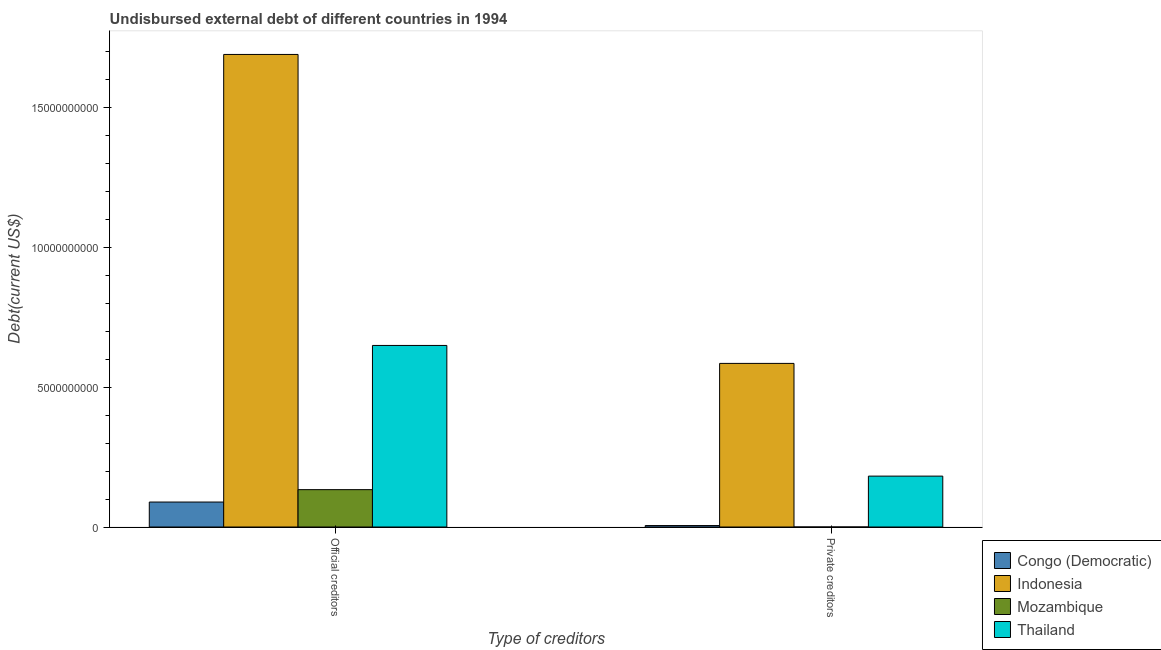How many groups of bars are there?
Keep it short and to the point. 2. Are the number of bars per tick equal to the number of legend labels?
Your response must be concise. Yes. What is the label of the 1st group of bars from the left?
Make the answer very short. Official creditors. What is the undisbursed external debt of official creditors in Mozambique?
Provide a short and direct response. 1.34e+09. Across all countries, what is the maximum undisbursed external debt of private creditors?
Your answer should be compact. 5.85e+09. Across all countries, what is the minimum undisbursed external debt of official creditors?
Give a very brief answer. 8.93e+08. In which country was the undisbursed external debt of private creditors minimum?
Give a very brief answer. Mozambique. What is the total undisbursed external debt of official creditors in the graph?
Give a very brief answer. 2.56e+1. What is the difference between the undisbursed external debt of private creditors in Mozambique and that in Thailand?
Provide a succinct answer. -1.82e+09. What is the difference between the undisbursed external debt of private creditors in Indonesia and the undisbursed external debt of official creditors in Mozambique?
Offer a very short reply. 4.52e+09. What is the average undisbursed external debt of official creditors per country?
Ensure brevity in your answer.  6.41e+09. What is the difference between the undisbursed external debt of official creditors and undisbursed external debt of private creditors in Congo (Democratic)?
Your answer should be compact. 8.41e+08. In how many countries, is the undisbursed external debt of private creditors greater than 7000000000 US$?
Your response must be concise. 0. What is the ratio of the undisbursed external debt of official creditors in Thailand to that in Congo (Democratic)?
Ensure brevity in your answer.  7.27. Is the undisbursed external debt of official creditors in Congo (Democratic) less than that in Mozambique?
Ensure brevity in your answer.  Yes. In how many countries, is the undisbursed external debt of private creditors greater than the average undisbursed external debt of private creditors taken over all countries?
Your answer should be compact. 1. What does the 1st bar from the left in Private creditors represents?
Your answer should be very brief. Congo (Democratic). What does the 4th bar from the right in Private creditors represents?
Make the answer very short. Congo (Democratic). How many bars are there?
Your answer should be compact. 8. How many countries are there in the graph?
Offer a very short reply. 4. What is the difference between two consecutive major ticks on the Y-axis?
Offer a terse response. 5.00e+09. Does the graph contain any zero values?
Ensure brevity in your answer.  No. Does the graph contain grids?
Keep it short and to the point. No. Where does the legend appear in the graph?
Make the answer very short. Bottom right. How are the legend labels stacked?
Make the answer very short. Vertical. What is the title of the graph?
Your answer should be compact. Undisbursed external debt of different countries in 1994. Does "Greece" appear as one of the legend labels in the graph?
Offer a terse response. No. What is the label or title of the X-axis?
Make the answer very short. Type of creditors. What is the label or title of the Y-axis?
Give a very brief answer. Debt(current US$). What is the Debt(current US$) in Congo (Democratic) in Official creditors?
Keep it short and to the point. 8.93e+08. What is the Debt(current US$) in Indonesia in Official creditors?
Give a very brief answer. 1.69e+1. What is the Debt(current US$) in Mozambique in Official creditors?
Your answer should be compact. 1.34e+09. What is the Debt(current US$) in Thailand in Official creditors?
Your response must be concise. 6.49e+09. What is the Debt(current US$) in Congo (Democratic) in Private creditors?
Provide a succinct answer. 5.21e+07. What is the Debt(current US$) of Indonesia in Private creditors?
Offer a very short reply. 5.85e+09. What is the Debt(current US$) of Mozambique in Private creditors?
Offer a very short reply. 2.40e+04. What is the Debt(current US$) of Thailand in Private creditors?
Your answer should be very brief. 1.82e+09. Across all Type of creditors, what is the maximum Debt(current US$) in Congo (Democratic)?
Ensure brevity in your answer.  8.93e+08. Across all Type of creditors, what is the maximum Debt(current US$) in Indonesia?
Provide a short and direct response. 1.69e+1. Across all Type of creditors, what is the maximum Debt(current US$) in Mozambique?
Give a very brief answer. 1.34e+09. Across all Type of creditors, what is the maximum Debt(current US$) of Thailand?
Your answer should be very brief. 6.49e+09. Across all Type of creditors, what is the minimum Debt(current US$) of Congo (Democratic)?
Keep it short and to the point. 5.21e+07. Across all Type of creditors, what is the minimum Debt(current US$) of Indonesia?
Your response must be concise. 5.85e+09. Across all Type of creditors, what is the minimum Debt(current US$) of Mozambique?
Your answer should be very brief. 2.40e+04. Across all Type of creditors, what is the minimum Debt(current US$) of Thailand?
Offer a terse response. 1.82e+09. What is the total Debt(current US$) of Congo (Democratic) in the graph?
Provide a short and direct response. 9.45e+08. What is the total Debt(current US$) of Indonesia in the graph?
Make the answer very short. 2.28e+1. What is the total Debt(current US$) of Mozambique in the graph?
Your response must be concise. 1.34e+09. What is the total Debt(current US$) of Thailand in the graph?
Provide a short and direct response. 8.31e+09. What is the difference between the Debt(current US$) in Congo (Democratic) in Official creditors and that in Private creditors?
Your answer should be compact. 8.41e+08. What is the difference between the Debt(current US$) of Indonesia in Official creditors and that in Private creditors?
Your response must be concise. 1.10e+1. What is the difference between the Debt(current US$) of Mozambique in Official creditors and that in Private creditors?
Your answer should be compact. 1.34e+09. What is the difference between the Debt(current US$) of Thailand in Official creditors and that in Private creditors?
Give a very brief answer. 4.67e+09. What is the difference between the Debt(current US$) in Congo (Democratic) in Official creditors and the Debt(current US$) in Indonesia in Private creditors?
Keep it short and to the point. -4.96e+09. What is the difference between the Debt(current US$) in Congo (Democratic) in Official creditors and the Debt(current US$) in Mozambique in Private creditors?
Your answer should be compact. 8.93e+08. What is the difference between the Debt(current US$) of Congo (Democratic) in Official creditors and the Debt(current US$) of Thailand in Private creditors?
Your response must be concise. -9.27e+08. What is the difference between the Debt(current US$) in Indonesia in Official creditors and the Debt(current US$) in Mozambique in Private creditors?
Offer a terse response. 1.69e+1. What is the difference between the Debt(current US$) of Indonesia in Official creditors and the Debt(current US$) of Thailand in Private creditors?
Offer a terse response. 1.51e+1. What is the difference between the Debt(current US$) in Mozambique in Official creditors and the Debt(current US$) in Thailand in Private creditors?
Make the answer very short. -4.84e+08. What is the average Debt(current US$) of Congo (Democratic) per Type of creditors?
Offer a terse response. 4.73e+08. What is the average Debt(current US$) in Indonesia per Type of creditors?
Your response must be concise. 1.14e+1. What is the average Debt(current US$) in Mozambique per Type of creditors?
Your response must be concise. 6.68e+08. What is the average Debt(current US$) in Thailand per Type of creditors?
Offer a terse response. 4.16e+09. What is the difference between the Debt(current US$) of Congo (Democratic) and Debt(current US$) of Indonesia in Official creditors?
Offer a terse response. -1.60e+1. What is the difference between the Debt(current US$) in Congo (Democratic) and Debt(current US$) in Mozambique in Official creditors?
Give a very brief answer. -4.43e+08. What is the difference between the Debt(current US$) in Congo (Democratic) and Debt(current US$) in Thailand in Official creditors?
Offer a very short reply. -5.60e+09. What is the difference between the Debt(current US$) in Indonesia and Debt(current US$) in Mozambique in Official creditors?
Ensure brevity in your answer.  1.56e+1. What is the difference between the Debt(current US$) in Indonesia and Debt(current US$) in Thailand in Official creditors?
Your response must be concise. 1.04e+1. What is the difference between the Debt(current US$) in Mozambique and Debt(current US$) in Thailand in Official creditors?
Ensure brevity in your answer.  -5.16e+09. What is the difference between the Debt(current US$) of Congo (Democratic) and Debt(current US$) of Indonesia in Private creditors?
Give a very brief answer. -5.80e+09. What is the difference between the Debt(current US$) in Congo (Democratic) and Debt(current US$) in Mozambique in Private creditors?
Give a very brief answer. 5.20e+07. What is the difference between the Debt(current US$) in Congo (Democratic) and Debt(current US$) in Thailand in Private creditors?
Provide a succinct answer. -1.77e+09. What is the difference between the Debt(current US$) in Indonesia and Debt(current US$) in Mozambique in Private creditors?
Provide a succinct answer. 5.85e+09. What is the difference between the Debt(current US$) of Indonesia and Debt(current US$) of Thailand in Private creditors?
Your answer should be compact. 4.03e+09. What is the difference between the Debt(current US$) of Mozambique and Debt(current US$) of Thailand in Private creditors?
Give a very brief answer. -1.82e+09. What is the ratio of the Debt(current US$) in Congo (Democratic) in Official creditors to that in Private creditors?
Keep it short and to the point. 17.16. What is the ratio of the Debt(current US$) of Indonesia in Official creditors to that in Private creditors?
Offer a terse response. 2.89. What is the ratio of the Debt(current US$) of Mozambique in Official creditors to that in Private creditors?
Your answer should be very brief. 5.57e+04. What is the ratio of the Debt(current US$) of Thailand in Official creditors to that in Private creditors?
Give a very brief answer. 3.57. What is the difference between the highest and the second highest Debt(current US$) in Congo (Democratic)?
Ensure brevity in your answer.  8.41e+08. What is the difference between the highest and the second highest Debt(current US$) in Indonesia?
Your response must be concise. 1.10e+1. What is the difference between the highest and the second highest Debt(current US$) in Mozambique?
Your response must be concise. 1.34e+09. What is the difference between the highest and the second highest Debt(current US$) of Thailand?
Offer a very short reply. 4.67e+09. What is the difference between the highest and the lowest Debt(current US$) of Congo (Democratic)?
Make the answer very short. 8.41e+08. What is the difference between the highest and the lowest Debt(current US$) of Indonesia?
Provide a short and direct response. 1.10e+1. What is the difference between the highest and the lowest Debt(current US$) of Mozambique?
Give a very brief answer. 1.34e+09. What is the difference between the highest and the lowest Debt(current US$) in Thailand?
Your answer should be compact. 4.67e+09. 